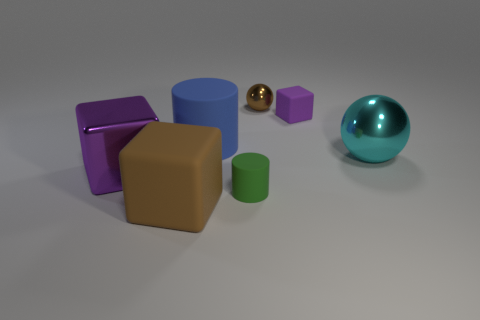Add 3 blue cylinders. How many objects exist? 10 Subtract all cylinders. How many objects are left? 5 Add 4 brown shiny objects. How many brown shiny objects are left? 5 Add 6 big purple shiny objects. How many big purple shiny objects exist? 7 Subtract 0 gray cylinders. How many objects are left? 7 Subtract all green metallic blocks. Subtract all brown balls. How many objects are left? 6 